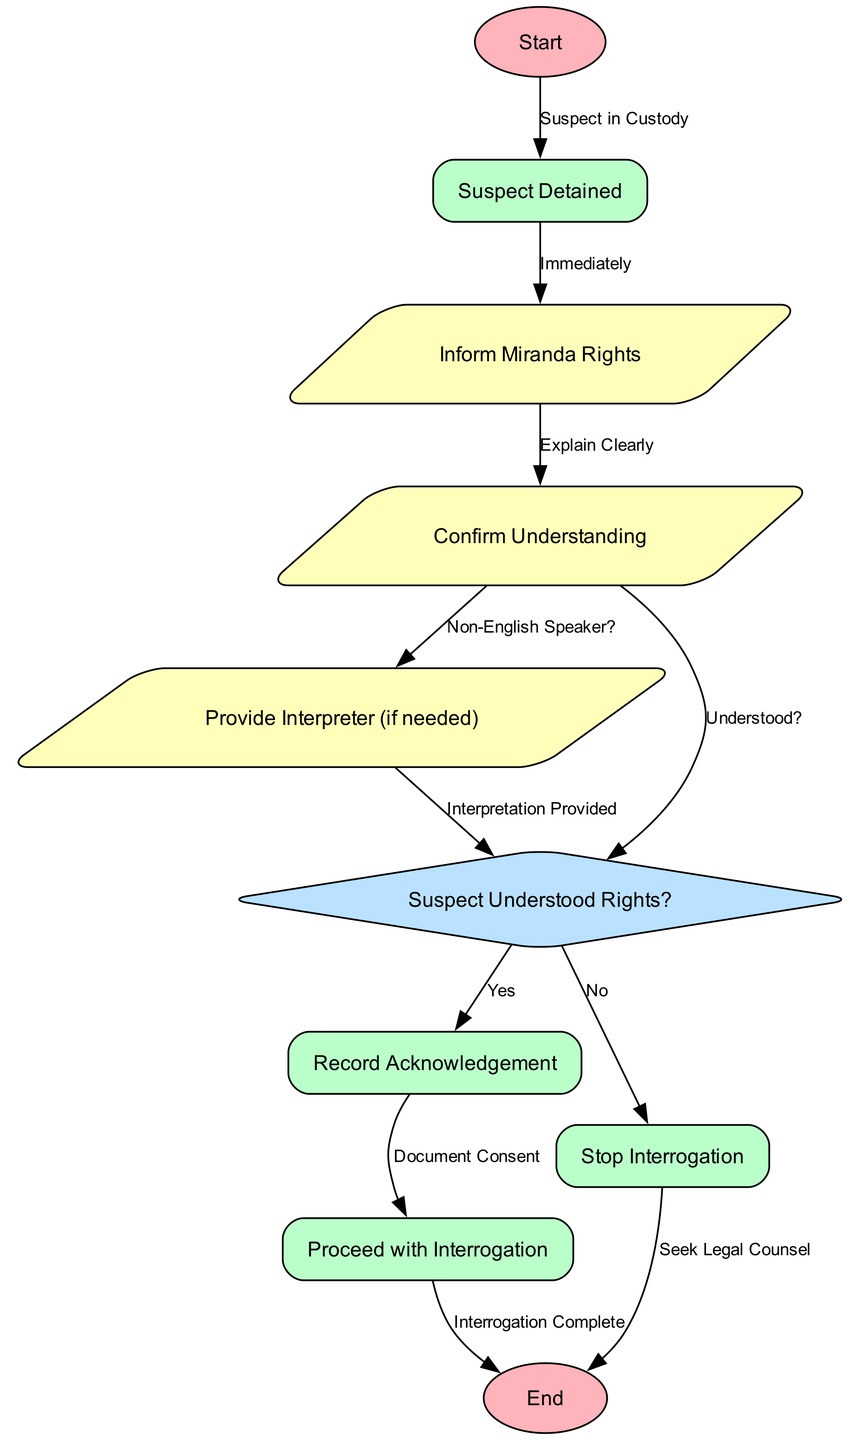What triggers the flowchart to start? The flowchart begins with the node labeled "Start", which is connected to "Suspect Detained" indicating that the suspect is in custody.
Answer: Suspect in Custody How many key steps are there in the process before the end node? The steps can be counted from "Suspect Detained" to "End". They are: "Suspect Detained", "Inform Miranda Rights", "Confirm Understanding", "Provide Interpreter", "Understood Rights?", "Record Acknowledgement", "Proceed with Interrogation", and "Stop Interrogation". There are a total of 8 main steps.
Answer: 8 What should the officer do if the suspect is a non-English speaker? If the suspect is a non-English speaker, the officer should provide an interpreter as indicated in the flow from "Confirm Understanding" to "Provide Interpreter".
Answer: Provide Interpreter What is the result if the suspect confirms understanding of their rights? If the suspect confirms understanding, the flowchart indicates moving to "Record Acknowledgement" followed by "Proceed with Interrogation".
Answer: Record Acknowledgement What happens if the suspect does not understand their rights? If the suspect does not understand their rights, the diagram specifies to "Stop Interrogation" and then "Seek Legal Counsel".
Answer: Stop Interrogation How many decision nodes are present in the flowchart? The flowchart has one decision node, which is "Suspect Understood Rights?" that dictates whether to proceed or stop based on the suspect's understanding.
Answer: 1 What must be done immediately after detaining the suspect according to the flowchart? Immediately after detaining the suspect, the officer is required to "Inform Miranda Rights" as per the flow from "Suspect Detained".
Answer: Inform Miranda Rights What does the edge labeled "Document Consent" indicate about the procedure? The edge labeled "Document Consent" indicates that after the suspect acknowledges understanding of their rights, it is crucial to record this acknowledgment before proceeding with the interrogation.
Answer: Document Consent 